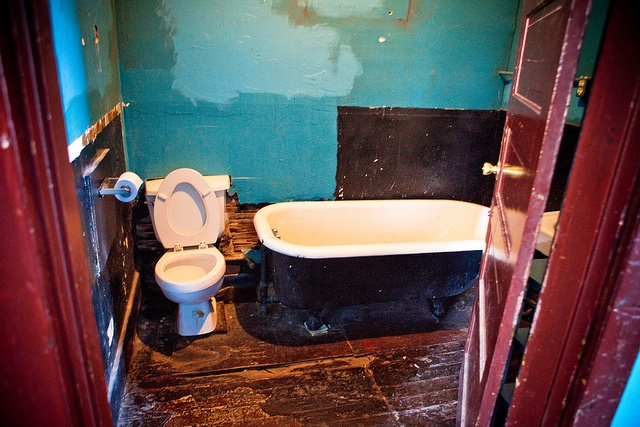Describe the objects in this image and their specific colors. I can see toilet in black, tan, lightgray, and gray tones and sink in black, tan, and salmon tones in this image. 